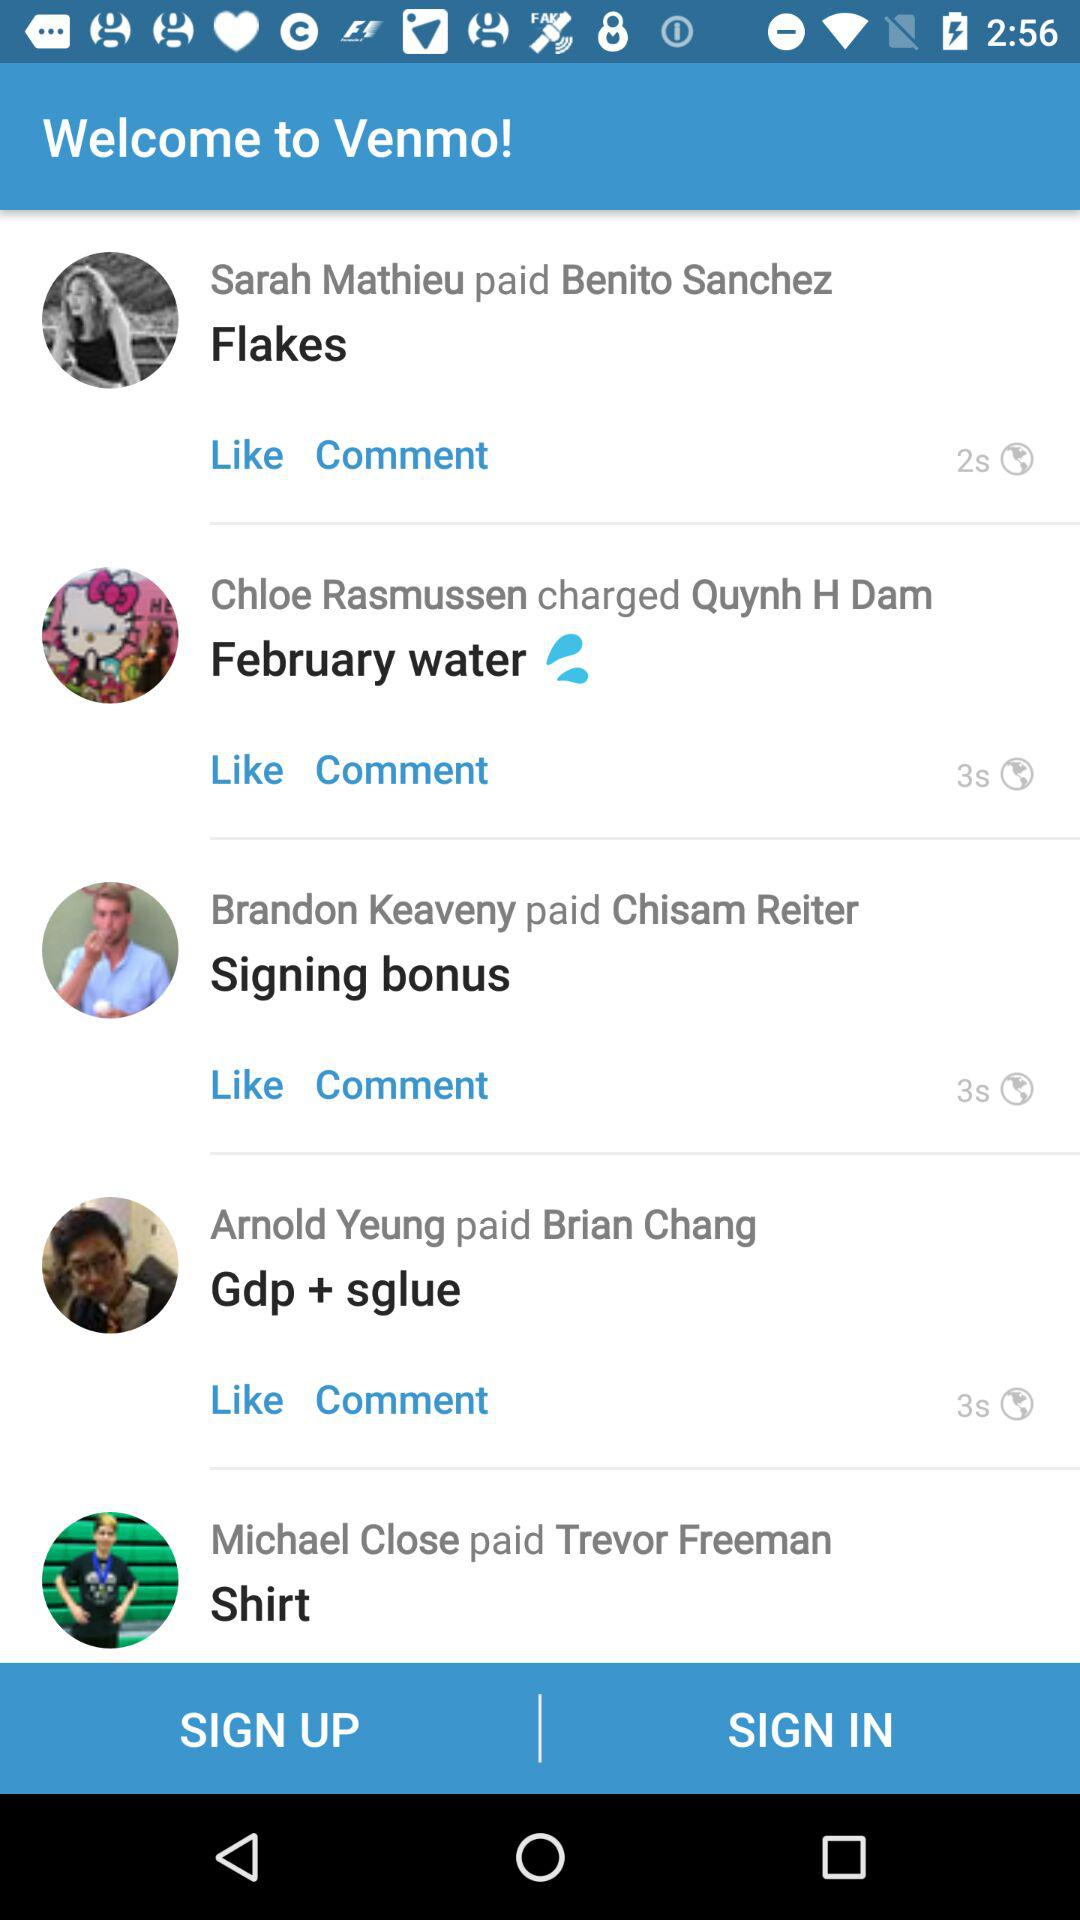Who paid Brian Chang? Brian Chang was paid by Arnold Yeung. 